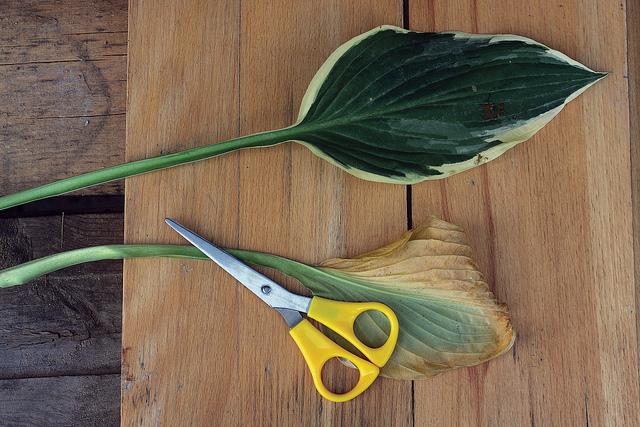What is the name of the tool used to cut these?
Short answer required. Scissors. What is unusual about the English language term used to describe the cutting tool?
Answer briefly. Scissors. What color are the scissor handles?
Quick response, please. Yellow. 